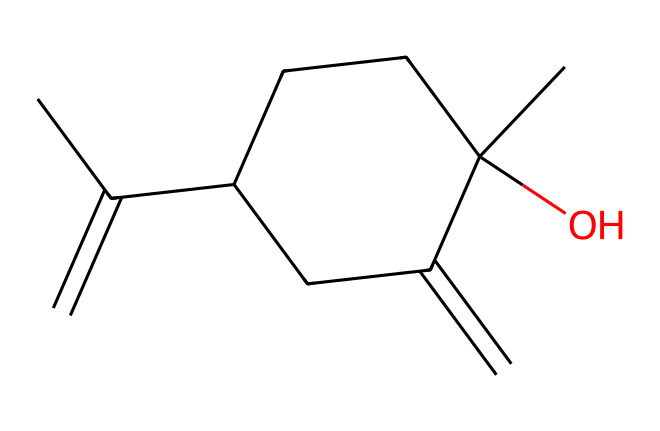How many carbon atoms are present in the structure? By interpreting the SMILES representation, we can count the carbon (C) atoms directly. The string CC(=C)C1CCC(C)(O)C(=C)C1 shows multiple 'C' characters. In total, there are 10 carbon atoms.
Answer: 10 What is the functional group observed in this chemical? The presence of the -OH group attached to a carbon indicates that there is an alcohol functional group in the structure. The 'C(C)(O)' portion of the SMILES indicates this group.
Answer: alcohol How many rings does the chemical structure contain? Looking at the structure, we can identify that there is one cyclic component represented by 'C1...C1', indicating a single ring is present in the molecule.
Answer: 1 What is the degree of unsaturation in the molecule? The degree of unsaturation can be calculated by identifying rings and double bonds. Each ring or double bond contributes to a degree of unsaturation. Here, there are 2 double bonds and 1 ring, leading to a total of 3 degrees of unsaturation.
Answer: 3 What type of solvent is lavender essential oil classified as? Given that lavender essential oil is derived from plants and primarily made up of volatile compounds, it is classified as a natural solvent.
Answer: natural solvent What might be the primary property of this solvent that promotes relaxation? The presence of linalool, a common aromatic compound in lavender essential oil, is known for its calming effects. The SMILES codes suggest the essential oil contains compounds that can promote relaxation, highlighting its use in aromatherapy.
Answer: calming 